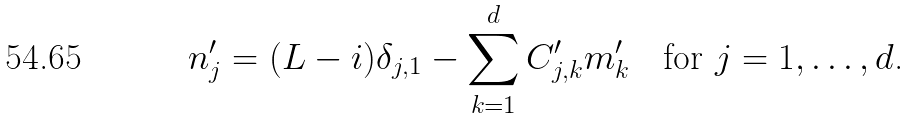<formula> <loc_0><loc_0><loc_500><loc_500>n ^ { \prime } _ { j } = ( L - i ) \delta _ { j , 1 } - \sum _ { k = 1 } ^ { d } C ^ { \prime } _ { j , k } m ^ { \prime } _ { k } \quad \text {for $j=1,\dots,d$.}</formula> 